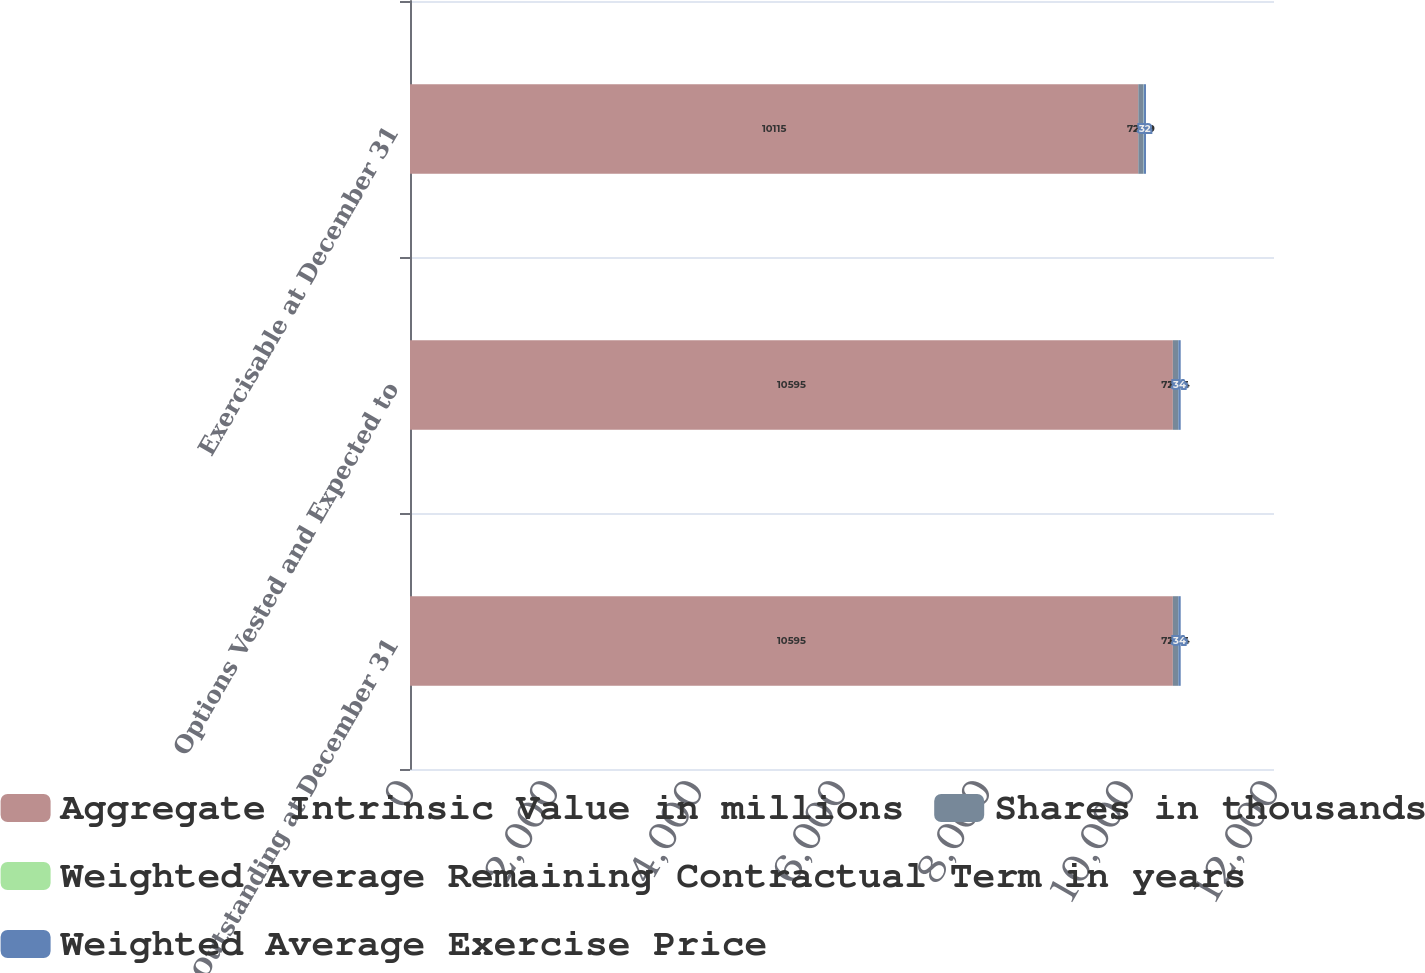Convert chart to OTSL. <chart><loc_0><loc_0><loc_500><loc_500><stacked_bar_chart><ecel><fcel>Outstanding at December 31<fcel>Options Vested and Expected to<fcel>Exercisable at December 31<nl><fcel>Aggregate Intrinsic Value in millions<fcel>10595<fcel>10595<fcel>10115<nl><fcel>Shares in thousands<fcel>72.04<fcel>72.04<fcel>72.09<nl><fcel>Weighted Average Remaining Contractual Term in years<fcel>3.03<fcel>3.03<fcel>2.79<nl><fcel>Weighted Average Exercise Price<fcel>34<fcel>34<fcel>32<nl></chart> 